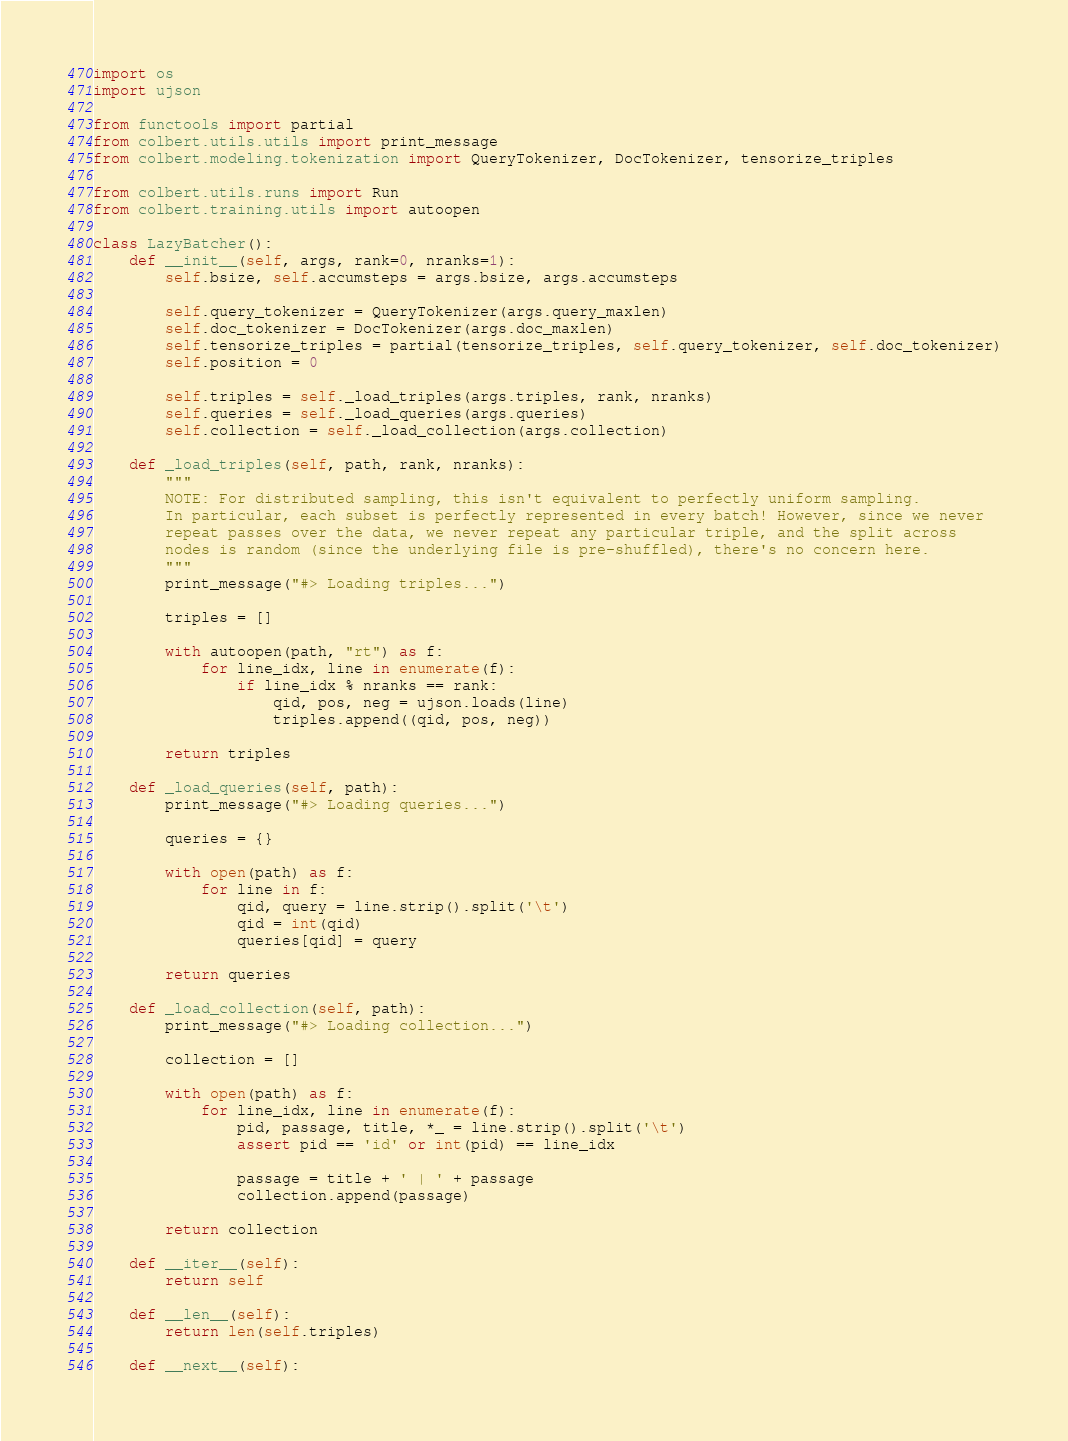<code> <loc_0><loc_0><loc_500><loc_500><_Python_>import os
import ujson

from functools import partial
from colbert.utils.utils import print_message
from colbert.modeling.tokenization import QueryTokenizer, DocTokenizer, tensorize_triples

from colbert.utils.runs import Run
from colbert.training.utils import autoopen

class LazyBatcher():
    def __init__(self, args, rank=0, nranks=1):
        self.bsize, self.accumsteps = args.bsize, args.accumsteps

        self.query_tokenizer = QueryTokenizer(args.query_maxlen)
        self.doc_tokenizer = DocTokenizer(args.doc_maxlen)
        self.tensorize_triples = partial(tensorize_triples, self.query_tokenizer, self.doc_tokenizer)
        self.position = 0

        self.triples = self._load_triples(args.triples, rank, nranks)
        self.queries = self._load_queries(args.queries)
        self.collection = self._load_collection(args.collection)

    def _load_triples(self, path, rank, nranks):
        """
        NOTE: For distributed sampling, this isn't equivalent to perfectly uniform sampling.
        In particular, each subset is perfectly represented in every batch! However, since we never
        repeat passes over the data, we never repeat any particular triple, and the split across
        nodes is random (since the underlying file is pre-shuffled), there's no concern here.
        """
        print_message("#> Loading triples...")

        triples = []

        with autoopen(path, "rt") as f:
            for line_idx, line in enumerate(f):
                if line_idx % nranks == rank:
                    qid, pos, neg = ujson.loads(line)
                    triples.append((qid, pos, neg))

        return triples

    def _load_queries(self, path):
        print_message("#> Loading queries...")

        queries = {}

        with open(path) as f:
            for line in f:
                qid, query = line.strip().split('\t')
                qid = int(qid)
                queries[qid] = query

        return queries

    def _load_collection(self, path):
        print_message("#> Loading collection...")

        collection = []

        with open(path) as f:
            for line_idx, line in enumerate(f):
                pid, passage, title, *_ = line.strip().split('\t')
                assert pid == 'id' or int(pid) == line_idx

                passage = title + ' | ' + passage
                collection.append(passage)

        return collection

    def __iter__(self):
        return self

    def __len__(self):
        return len(self.triples)

    def __next__(self):</code> 